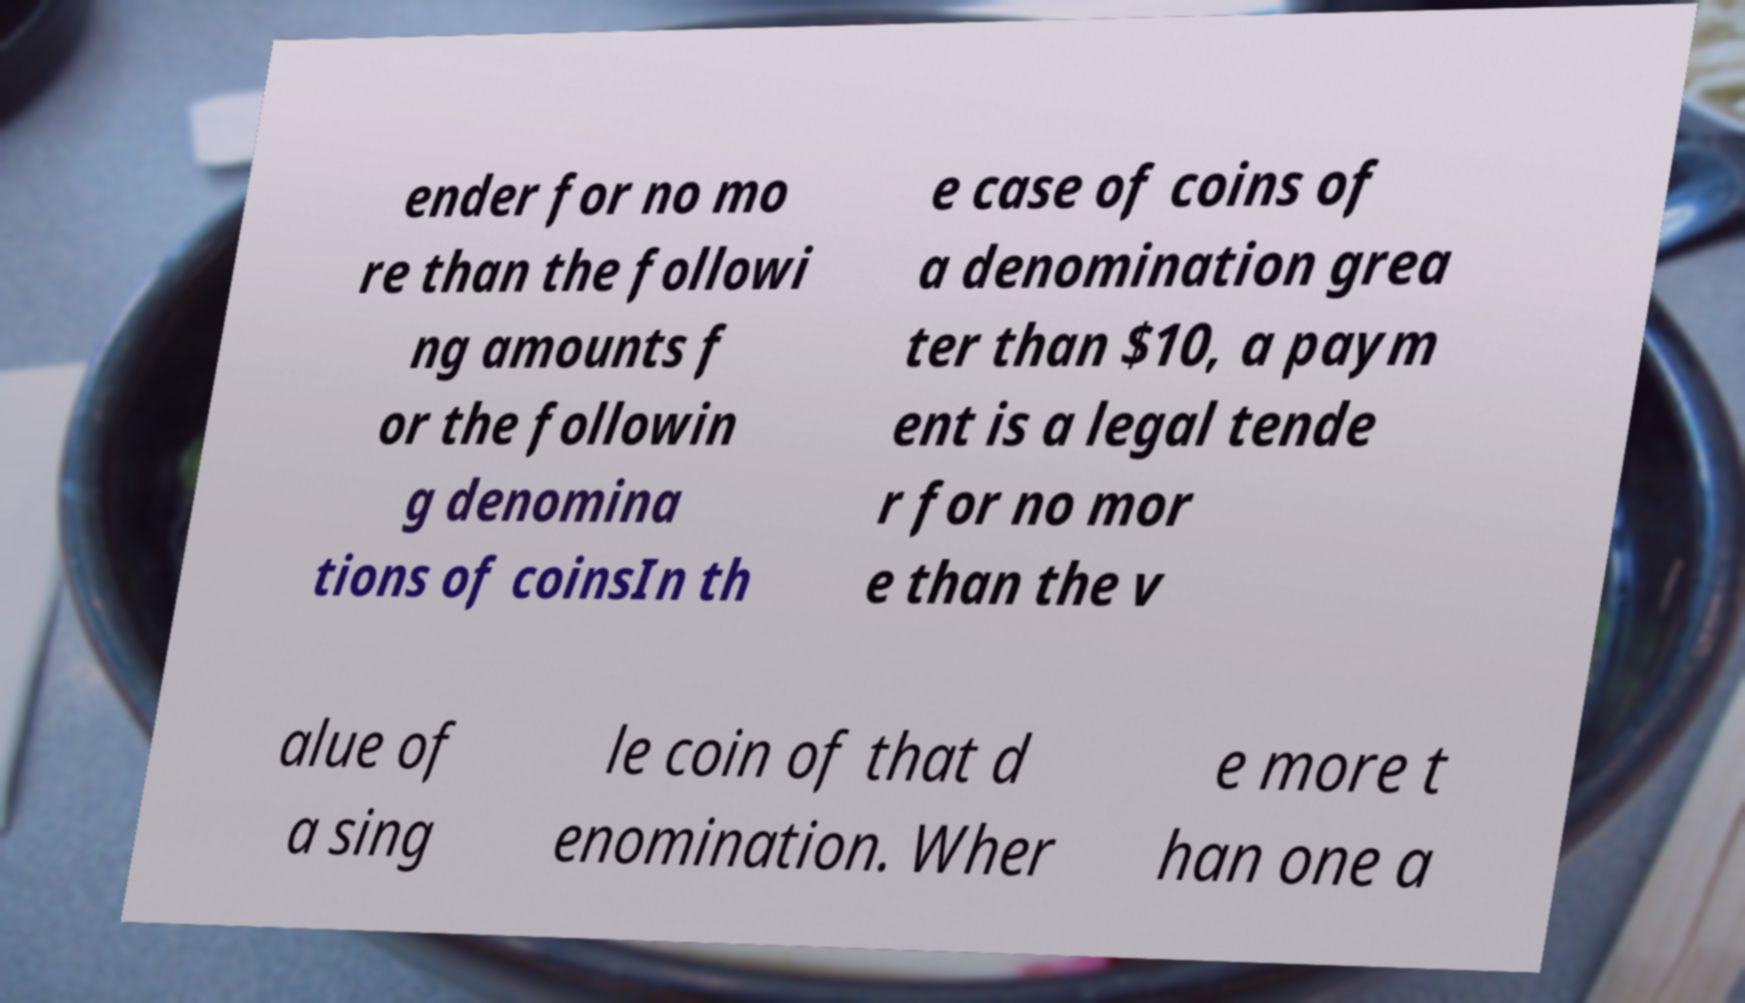Please read and relay the text visible in this image. What does it say? ender for no mo re than the followi ng amounts f or the followin g denomina tions of coinsIn th e case of coins of a denomination grea ter than $10, a paym ent is a legal tende r for no mor e than the v alue of a sing le coin of that d enomination. Wher e more t han one a 